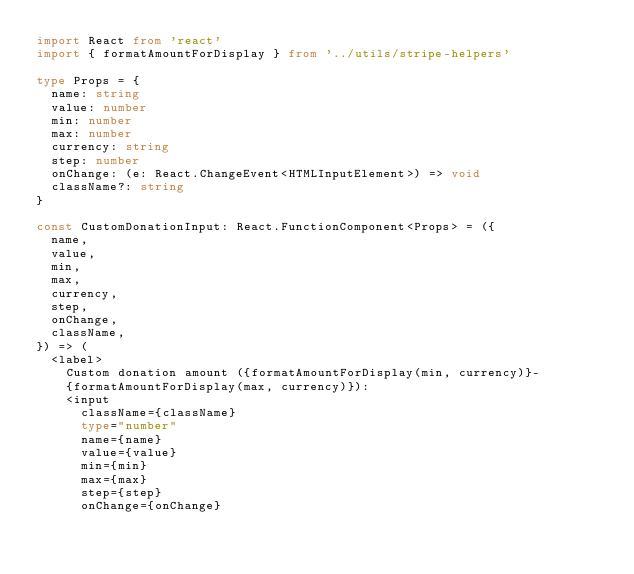<code> <loc_0><loc_0><loc_500><loc_500><_TypeScript_>import React from 'react'
import { formatAmountForDisplay } from '../utils/stripe-helpers'

type Props = {
  name: string
  value: number
  min: number
  max: number
  currency: string
  step: number
  onChange: (e: React.ChangeEvent<HTMLInputElement>) => void
  className?: string
}

const CustomDonationInput: React.FunctionComponent<Props> = ({
  name,
  value,
  min,
  max,
  currency,
  step,
  onChange,
  className,
}) => (
  <label>
    Custom donation amount ({formatAmountForDisplay(min, currency)}-
    {formatAmountForDisplay(max, currency)}):
    <input
      className={className}
      type="number"
      name={name}
      value={value}
      min={min}
      max={max}
      step={step}
      onChange={onChange}</code> 